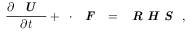Convert formula to latex. <formula><loc_0><loc_0><loc_500><loc_500>\frac { \partial \emph { U } } { \partial t } + \nabla \cdot \emph { F } = \emph { R H S } ,</formula> 